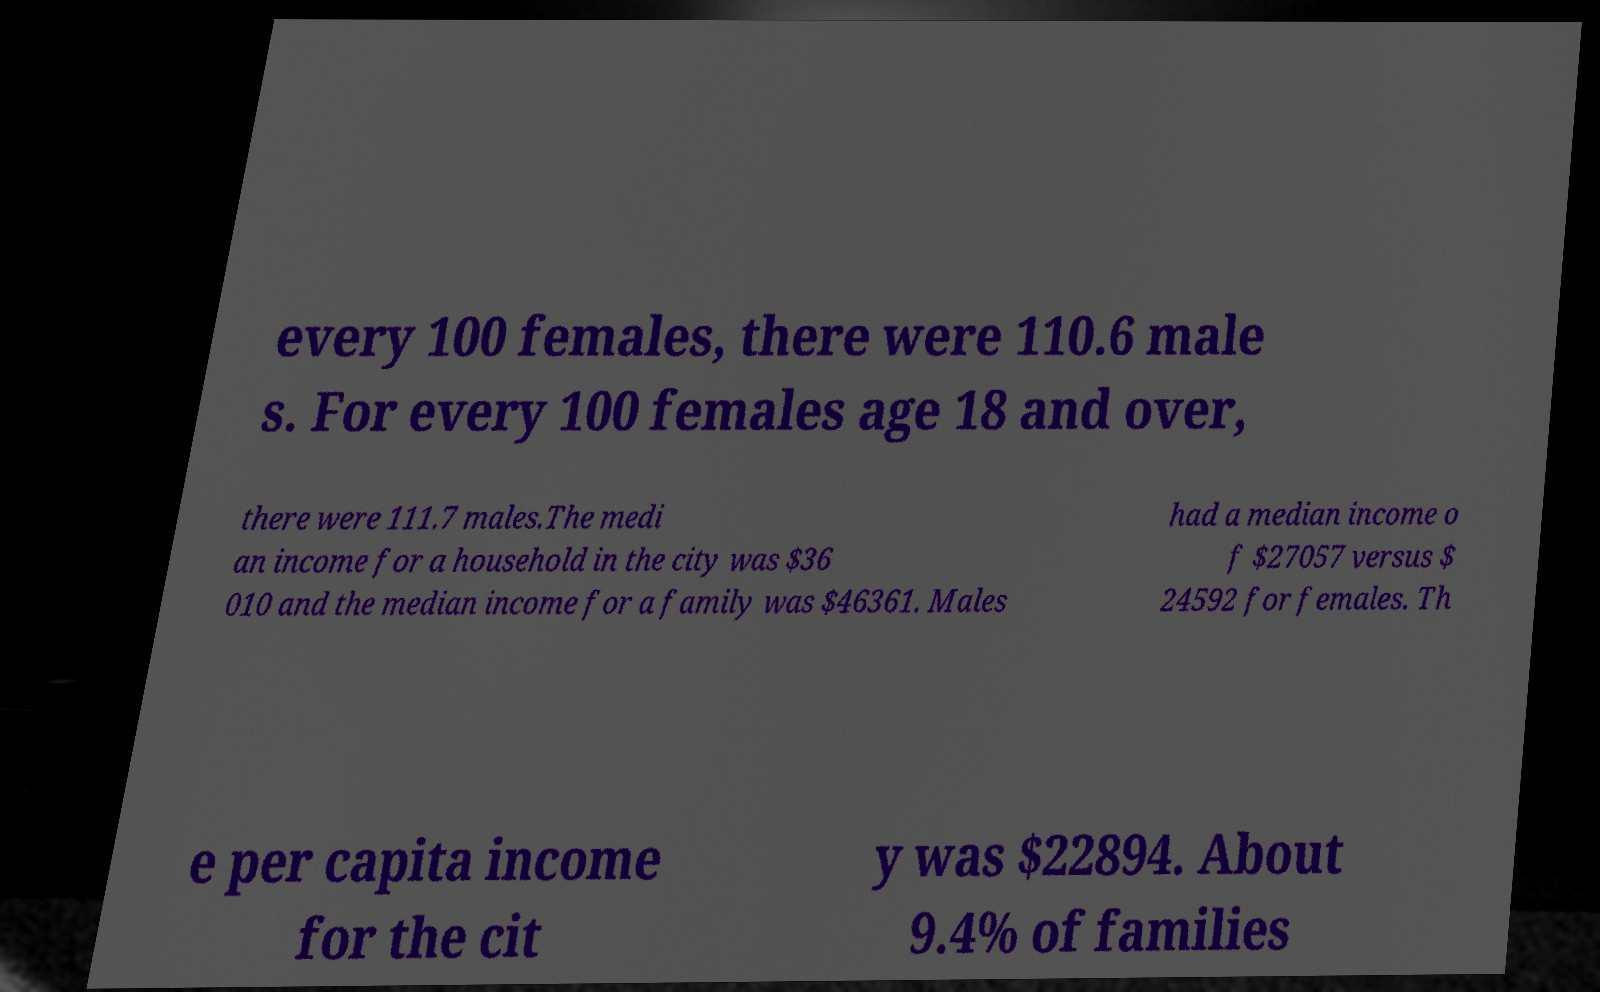For documentation purposes, I need the text within this image transcribed. Could you provide that? every 100 females, there were 110.6 male s. For every 100 females age 18 and over, there were 111.7 males.The medi an income for a household in the city was $36 010 and the median income for a family was $46361. Males had a median income o f $27057 versus $ 24592 for females. Th e per capita income for the cit y was $22894. About 9.4% of families 